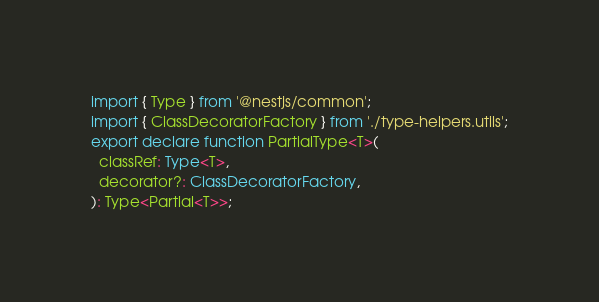Convert code to text. <code><loc_0><loc_0><loc_500><loc_500><_TypeScript_>import { Type } from '@nestjs/common';
import { ClassDecoratorFactory } from './type-helpers.utils';
export declare function PartialType<T>(
  classRef: Type<T>,
  decorator?: ClassDecoratorFactory,
): Type<Partial<T>>;
</code> 